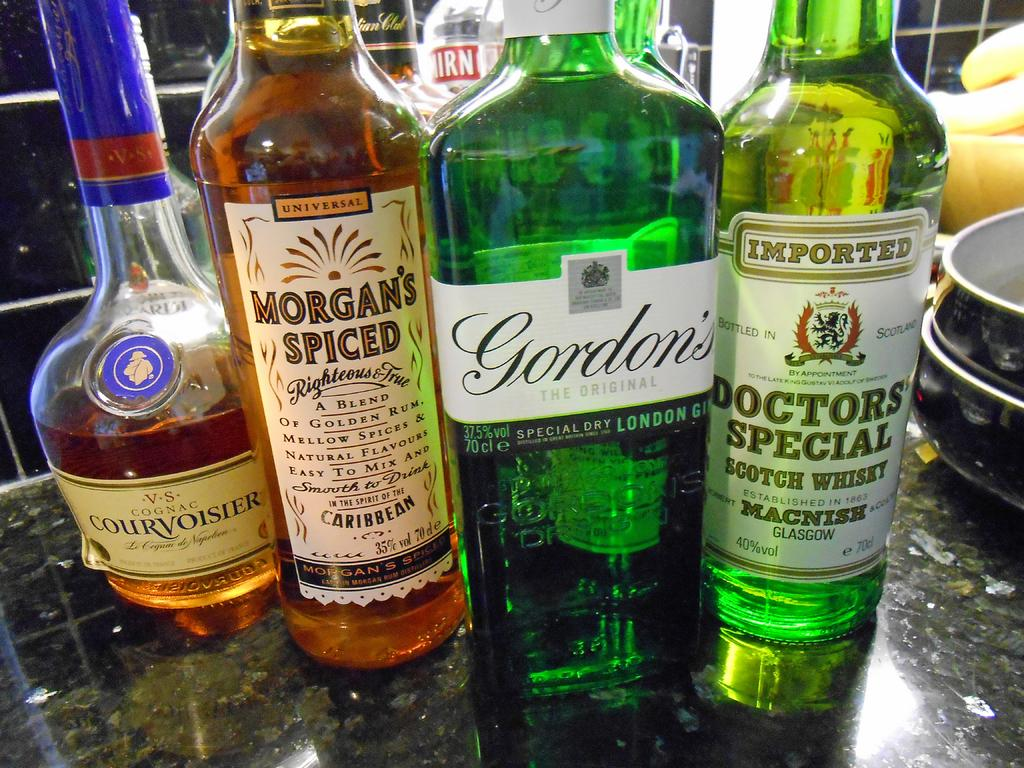Provide a one-sentence caption for the provided image. A few bottles of alcohol next to each other with Morgan's Spiced and Gordon's. 